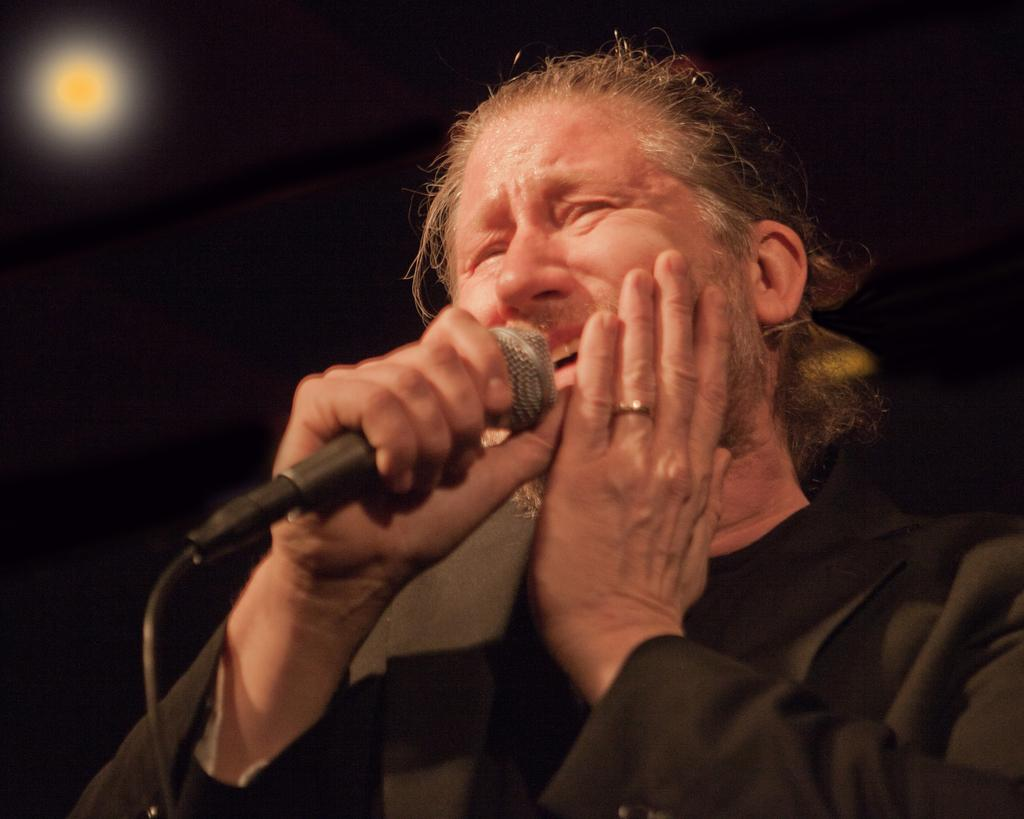What is the main subject of the image? The main subject of the image is a man. What is the man holding in the image? The man is holding a mic in the image. What activity is the man engaged in? The man appears to be singing in the image. How would you describe the lighting in the image? The background of the image is dark, but there is a light source in the background that resembles the moon. How many jellyfish can be seen swimming in the background of the image? There are no jellyfish present in the image; the background features a dark setting with a light source resembling the moon. 